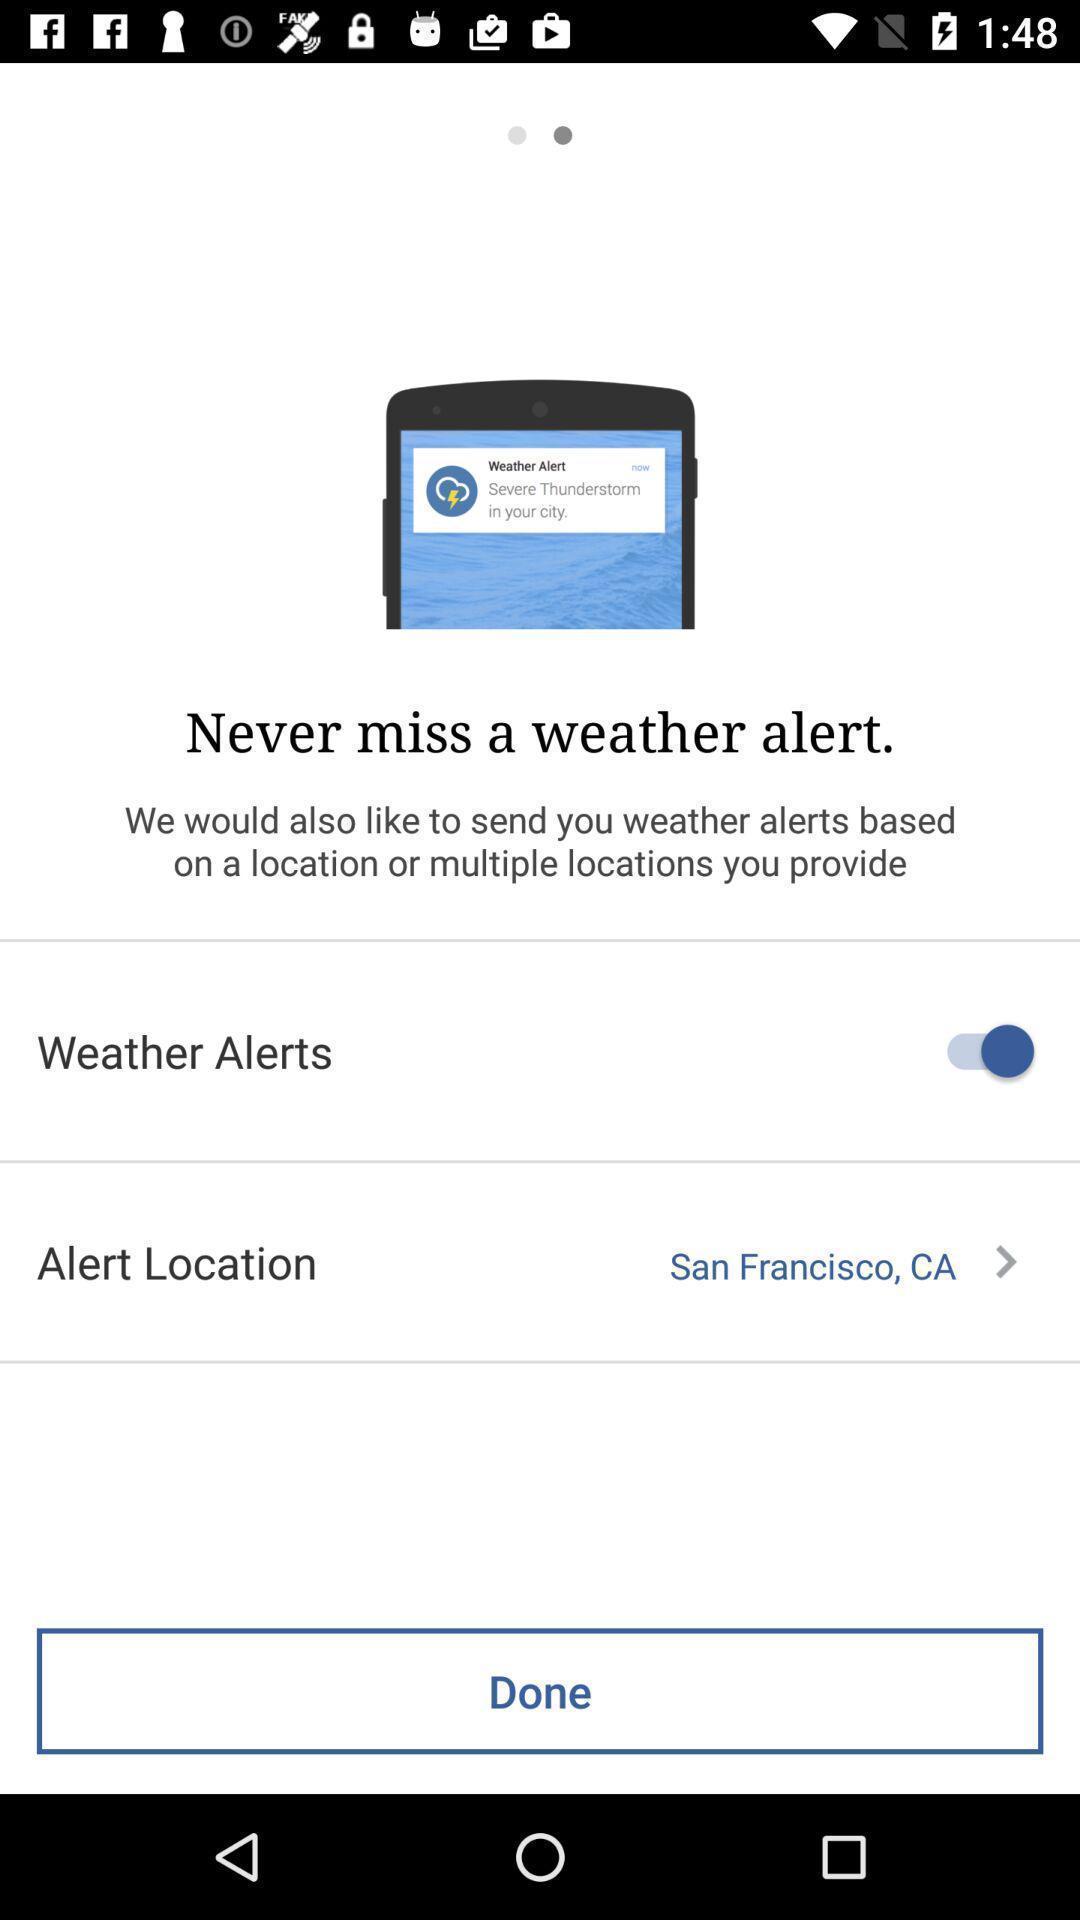Give me a summary of this screen capture. Showing the weather alert of the particular location. 